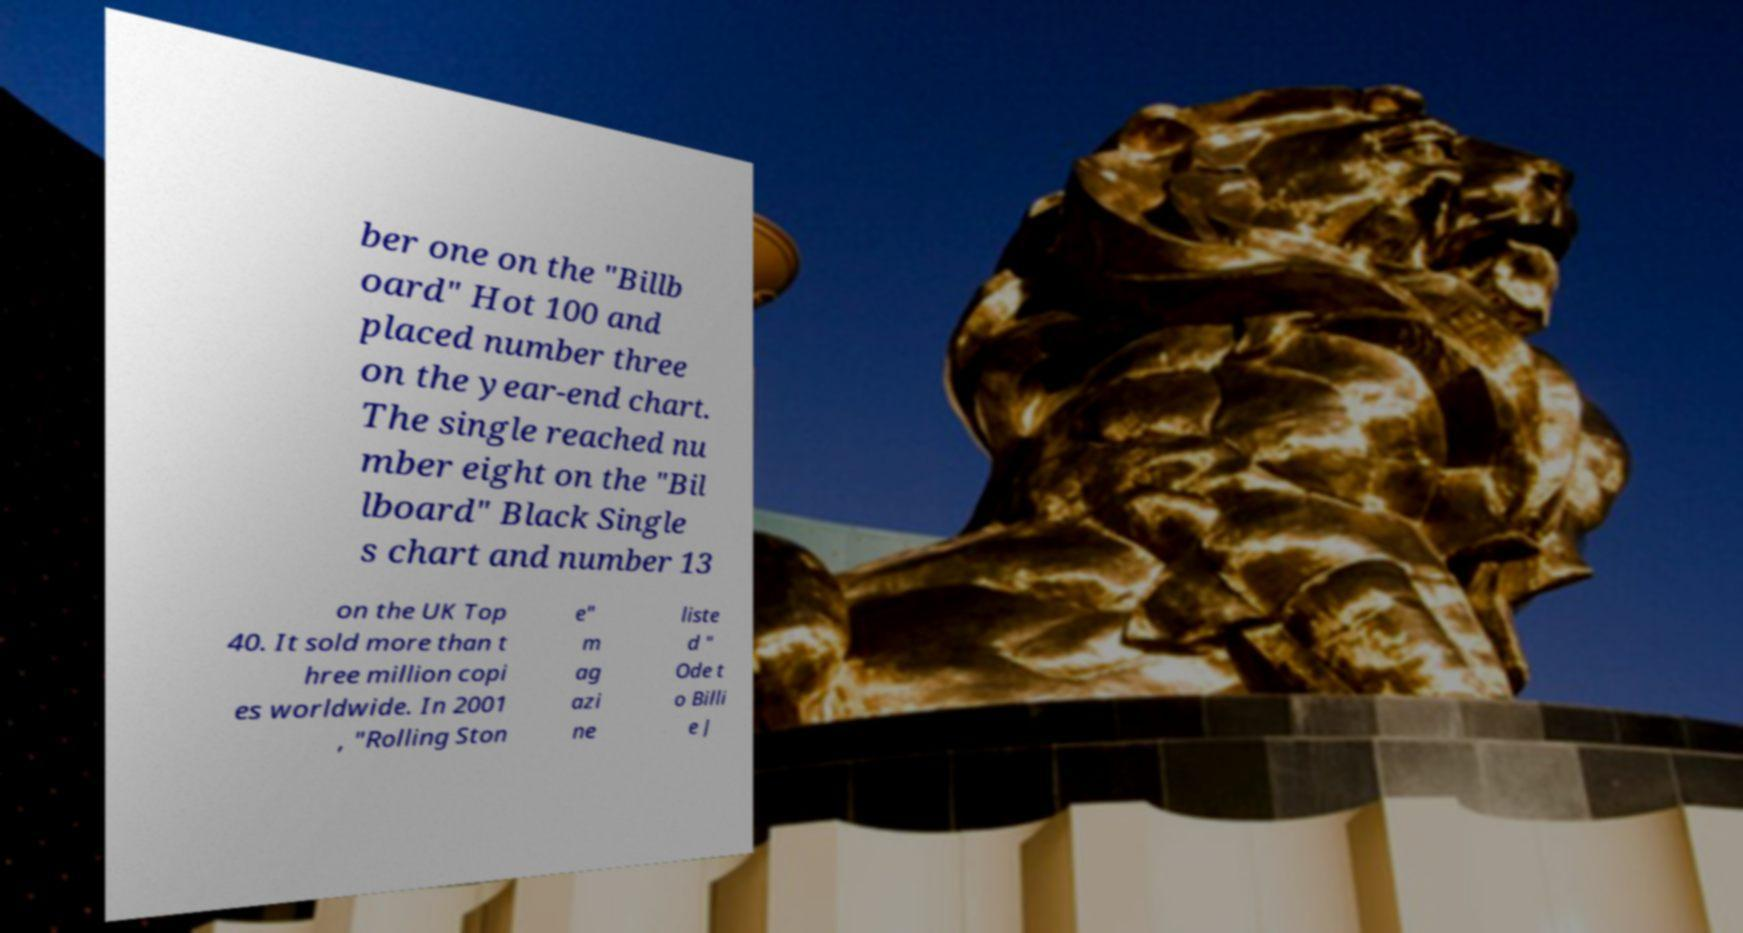What messages or text are displayed in this image? I need them in a readable, typed format. ber one on the "Billb oard" Hot 100 and placed number three on the year-end chart. The single reached nu mber eight on the "Bil lboard" Black Single s chart and number 13 on the UK Top 40. It sold more than t hree million copi es worldwide. In 2001 , "Rolling Ston e" m ag azi ne liste d " Ode t o Billi e J 